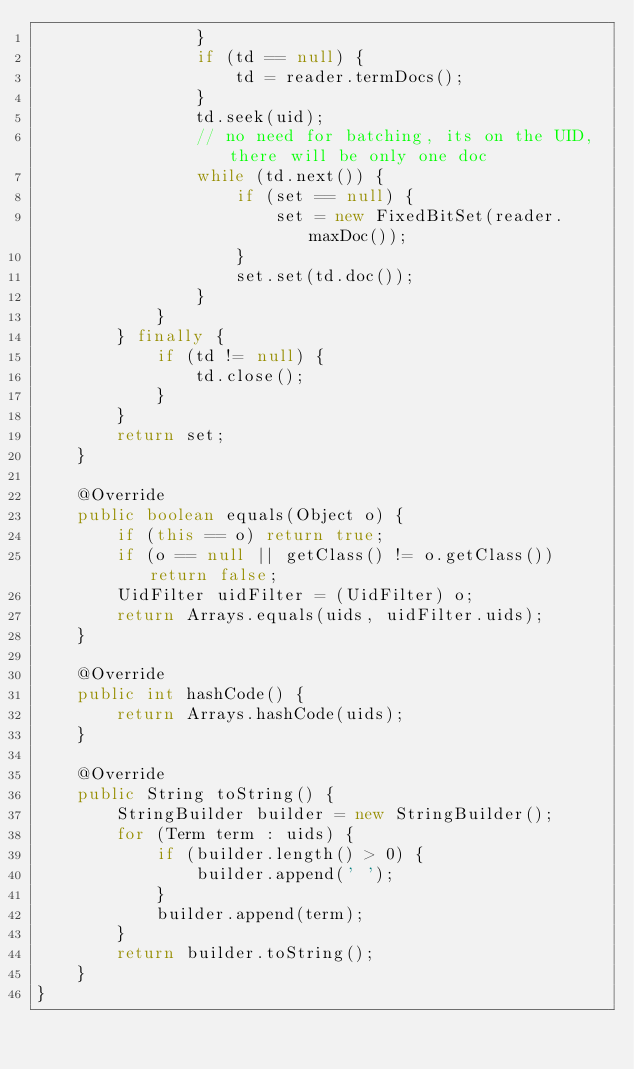<code> <loc_0><loc_0><loc_500><loc_500><_Java_>                }
                if (td == null) {
                    td = reader.termDocs();
                }
                td.seek(uid);
                // no need for batching, its on the UID, there will be only one doc
                while (td.next()) {
                    if (set == null) {
                        set = new FixedBitSet(reader.maxDoc());
                    }
                    set.set(td.doc());
                }
            }
        } finally {
            if (td != null) {
                td.close();
            }
        }
        return set;
    }

    @Override
    public boolean equals(Object o) {
        if (this == o) return true;
        if (o == null || getClass() != o.getClass()) return false;
        UidFilter uidFilter = (UidFilter) o;
        return Arrays.equals(uids, uidFilter.uids);
    }

    @Override
    public int hashCode() {
        return Arrays.hashCode(uids);
    }

    @Override
    public String toString() {
        StringBuilder builder = new StringBuilder();
        for (Term term : uids) {
            if (builder.length() > 0) {
                builder.append(' ');
            }
            builder.append(term);
        }
        return builder.toString();
    }
}</code> 